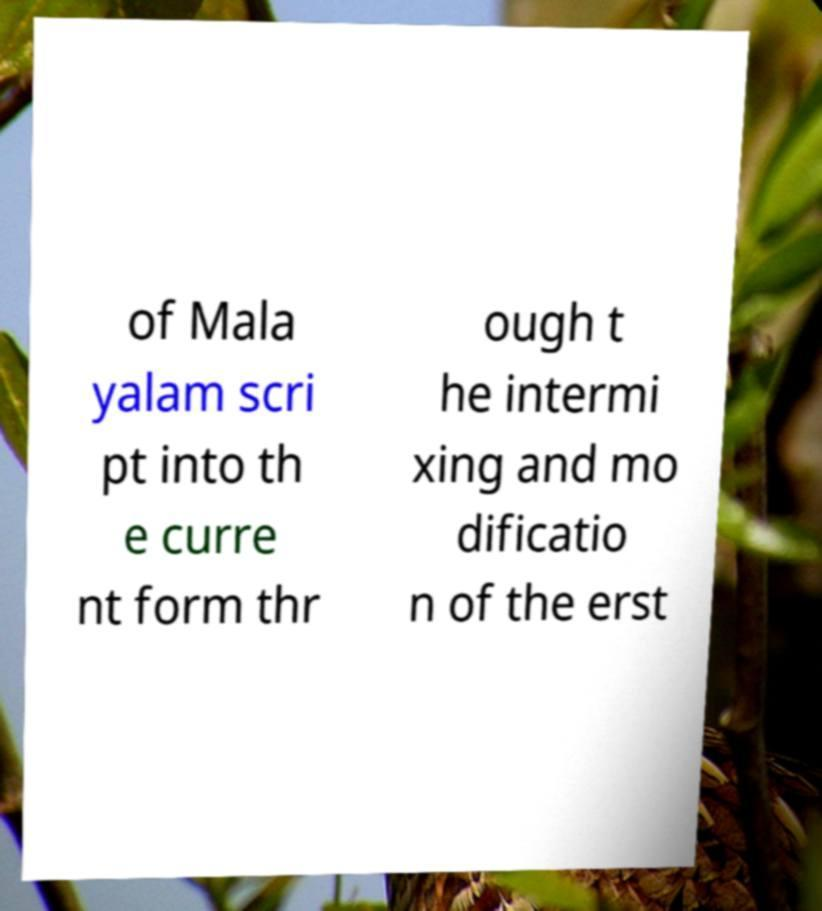I need the written content from this picture converted into text. Can you do that? of Mala yalam scri pt into th e curre nt form thr ough t he intermi xing and mo dificatio n of the erst 